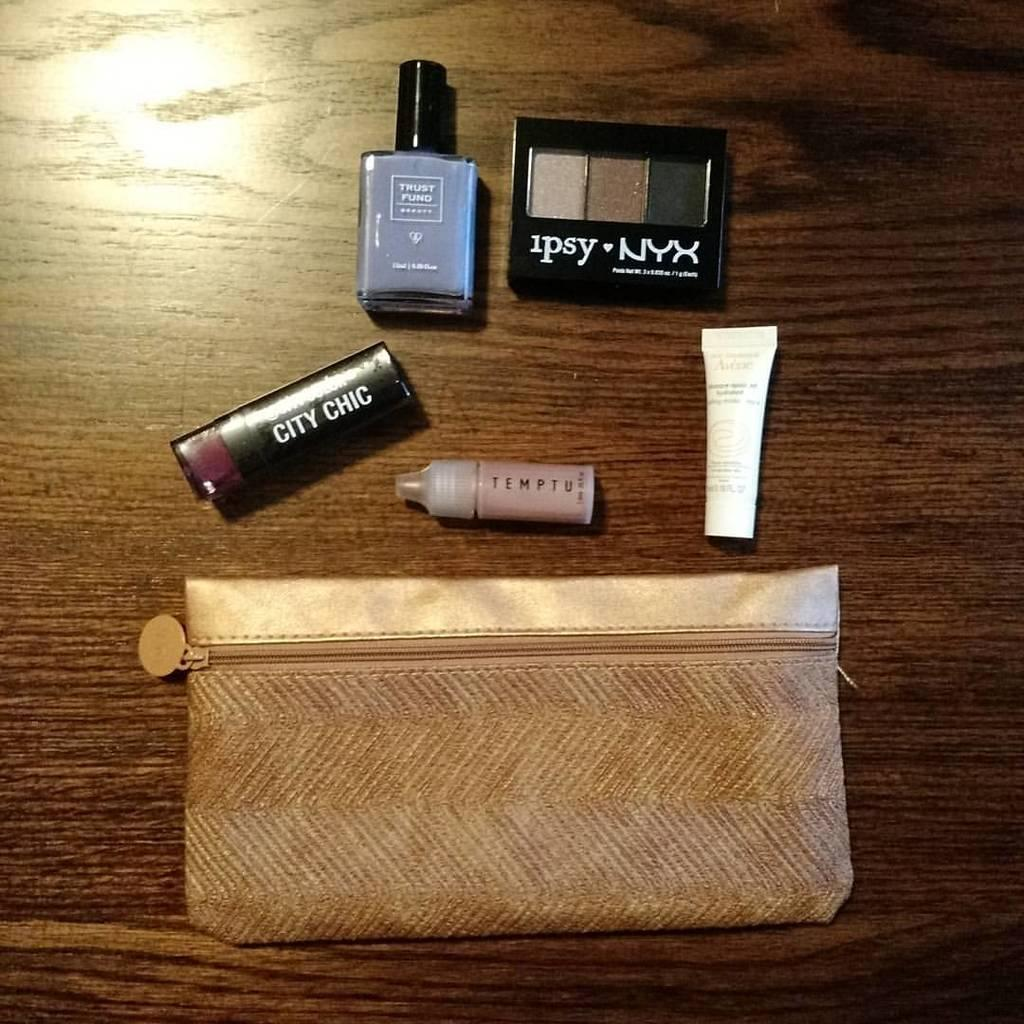<image>
Give a short and clear explanation of the subsequent image. City Chic lipstick next to a bottle that says Temptu. 